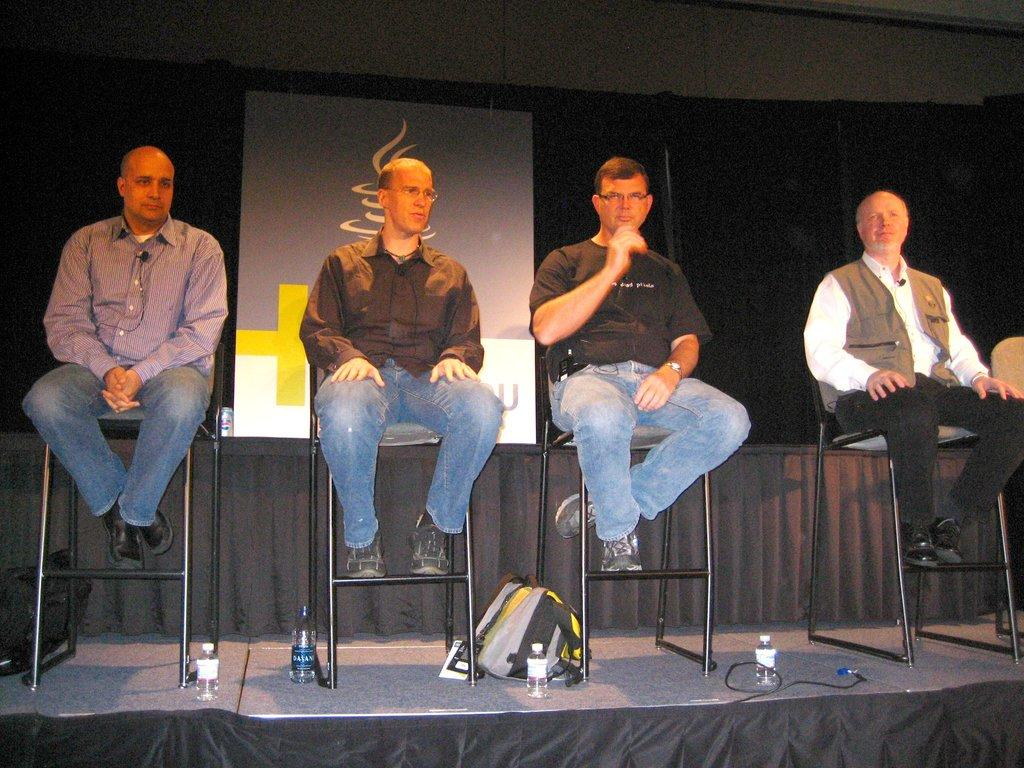How many people are sitting on chairs on the stage in the image? There are four people sitting on chairs on the stage in the image. What other items can be seen in the image besides the people on the stage? Bottles and bags are visible in the image. What is present in the background of the image? There is a board in the background of the image. What type of food is being served on the road in the image? There is no road or food present in the image; it features four people sitting on chairs on a stage with bottles and bags visible. 